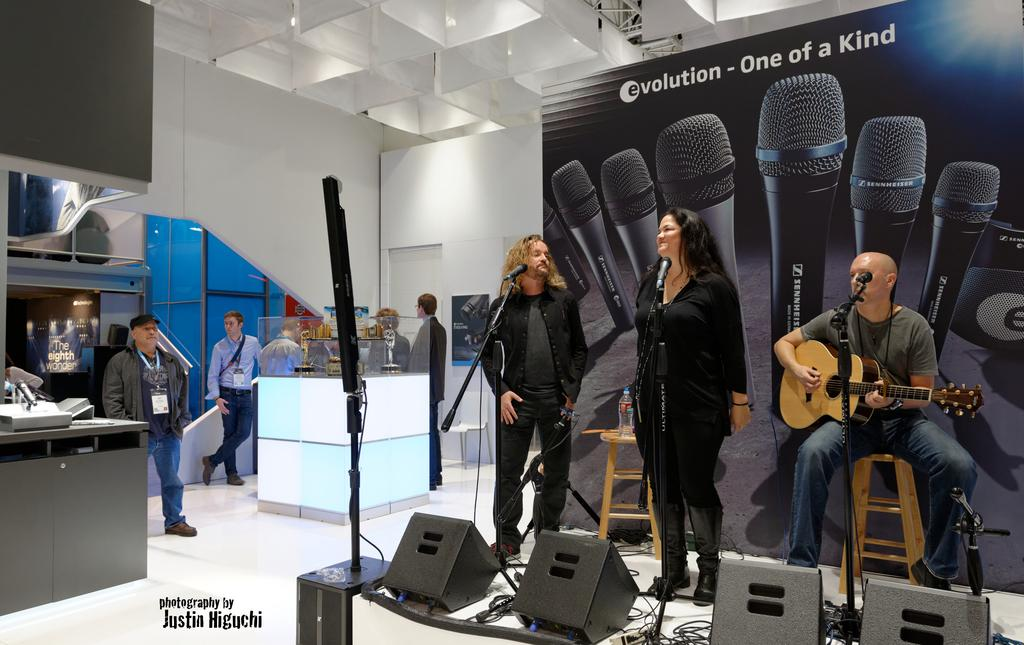How many people are in the image? There are people in the image, but the exact number is not specified. What is the man sitting on in the image? The man is sitting on a chair in the image. What is the man holding in the image? The man is holding a guitar in the image. What objects are in front of the people in the image? There are two microphones in front of the people in the image. What type of plantation can be seen in the background of the image? There is no plantation visible in the image; it only shows people, a man with a guitar, and two microphones. 